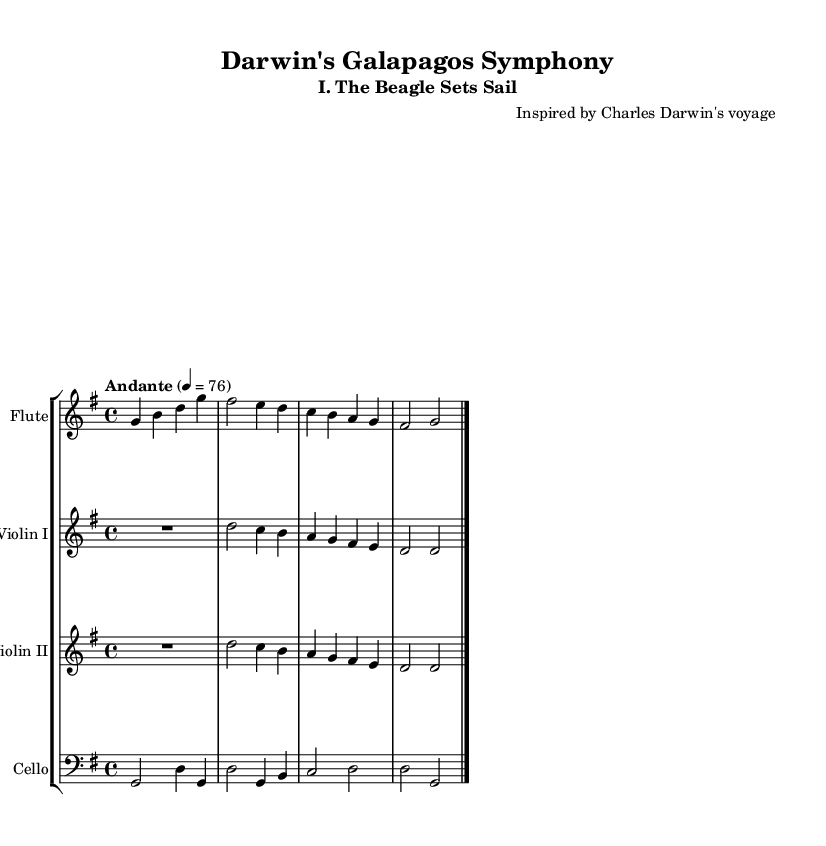What is the key signature of this music? The key signature is G major, which has one sharp (F#) indicated at the beginning of the staff.
Answer: G major What is the time signature of this composition? The time signature is 4/4, which means there are four beats per measure and the quarter note gets one beat, indicated at the beginning of the sheet music.
Answer: 4/4 What is the tempo marking for this piece? The tempo marking is Andante, indicating a moderate pace, and it is set to 76 beats per minute. This can be inferred from the tempo indication provided in the music.
Answer: Andante How many instruments are featured in this piece? There are four instruments featured: flute, violin I, violin II, and cello, as indicated by the separate staves for each instrument in the score.
Answer: Four Which instrument has the highest pitch range? The flute has the highest pitch range, as it typically plays in the highest register compared to the violin and cello, which are lower in pitch. This is recognizable by the positioning of the notes on the staff.
Answer: Flute What note duration is predominantly used in the opening phrase? The opening phrase primarily uses quarter notes, evidenced by the breakdown of notes in the flute part, with most notes being notated as quarter notes.
Answer: Quarter notes What is the first note played by the cello? The first note played by the cello is G, which is at the beginning of its musical line, stated in bass clef at the start of the cello staff.
Answer: G 